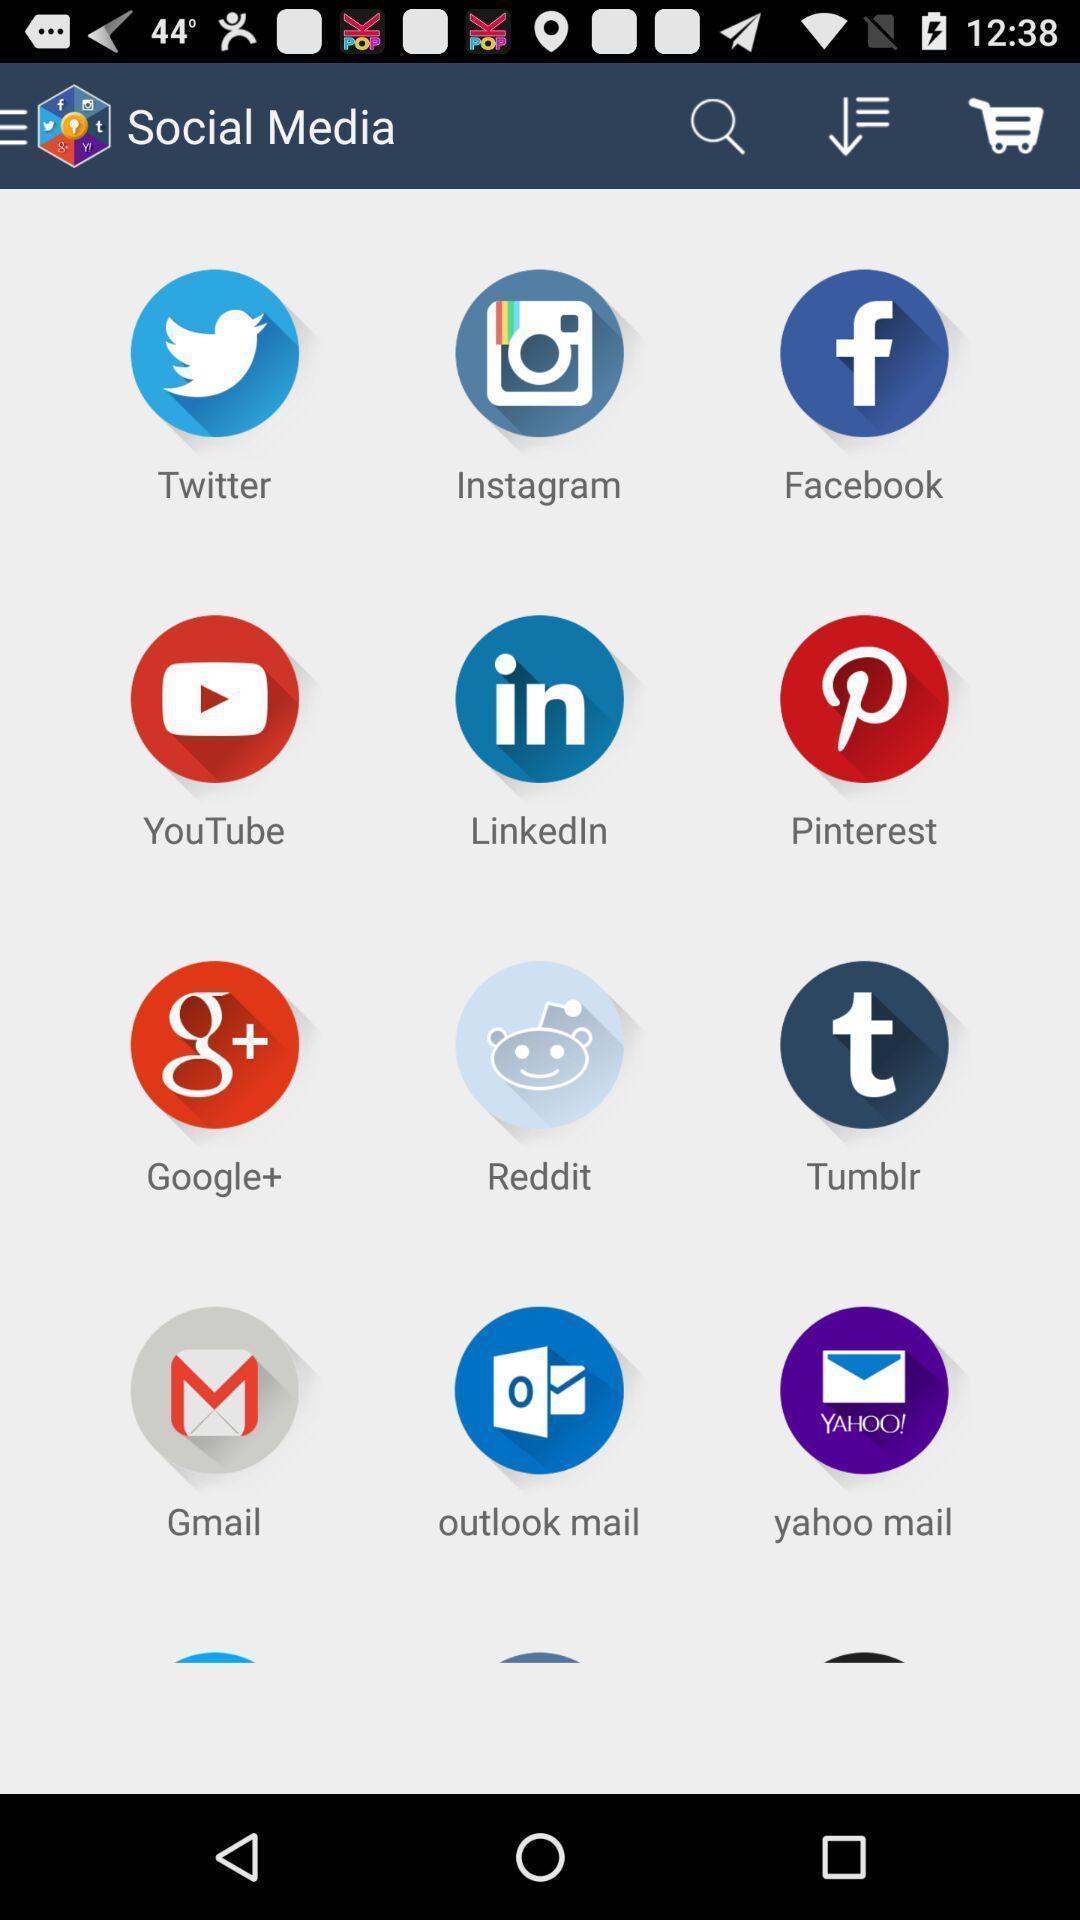What can you discern from this picture? Screen shows different social apps. 